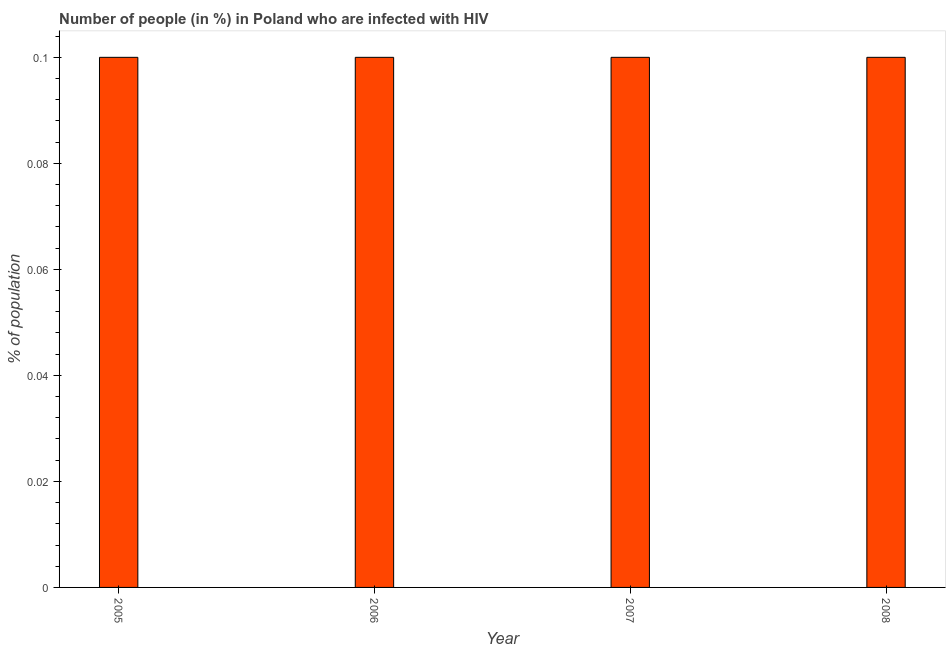Does the graph contain any zero values?
Your answer should be compact. No. What is the title of the graph?
Your answer should be very brief. Number of people (in %) in Poland who are infected with HIV. What is the label or title of the X-axis?
Provide a short and direct response. Year. What is the label or title of the Y-axis?
Your answer should be compact. % of population. What is the number of people infected with hiv in 2008?
Your response must be concise. 0.1. Across all years, what is the maximum number of people infected with hiv?
Provide a succinct answer. 0.1. In which year was the number of people infected with hiv maximum?
Provide a succinct answer. 2005. In which year was the number of people infected with hiv minimum?
Make the answer very short. 2005. What is the sum of the number of people infected with hiv?
Make the answer very short. 0.4. In how many years, is the number of people infected with hiv greater than 0.06 %?
Your answer should be compact. 4. Do a majority of the years between 2006 and 2007 (inclusive) have number of people infected with hiv greater than 0.024 %?
Offer a very short reply. Yes. What is the ratio of the number of people infected with hiv in 2005 to that in 2006?
Keep it short and to the point. 1. Is the number of people infected with hiv in 2005 less than that in 2006?
Your answer should be compact. No. Is the sum of the number of people infected with hiv in 2007 and 2008 greater than the maximum number of people infected with hiv across all years?
Your answer should be very brief. Yes. Are all the bars in the graph horizontal?
Offer a very short reply. No. How many years are there in the graph?
Offer a terse response. 4. Are the values on the major ticks of Y-axis written in scientific E-notation?
Ensure brevity in your answer.  No. What is the % of population in 2005?
Provide a succinct answer. 0.1. What is the % of population in 2006?
Ensure brevity in your answer.  0.1. What is the % of population in 2008?
Give a very brief answer. 0.1. What is the difference between the % of population in 2005 and 2006?
Your answer should be very brief. 0. What is the difference between the % of population in 2005 and 2008?
Ensure brevity in your answer.  0. What is the difference between the % of population in 2006 and 2008?
Provide a succinct answer. 0. What is the difference between the % of population in 2007 and 2008?
Your response must be concise. 0. What is the ratio of the % of population in 2005 to that in 2006?
Provide a short and direct response. 1. What is the ratio of the % of population in 2006 to that in 2008?
Offer a very short reply. 1. What is the ratio of the % of population in 2007 to that in 2008?
Offer a very short reply. 1. 